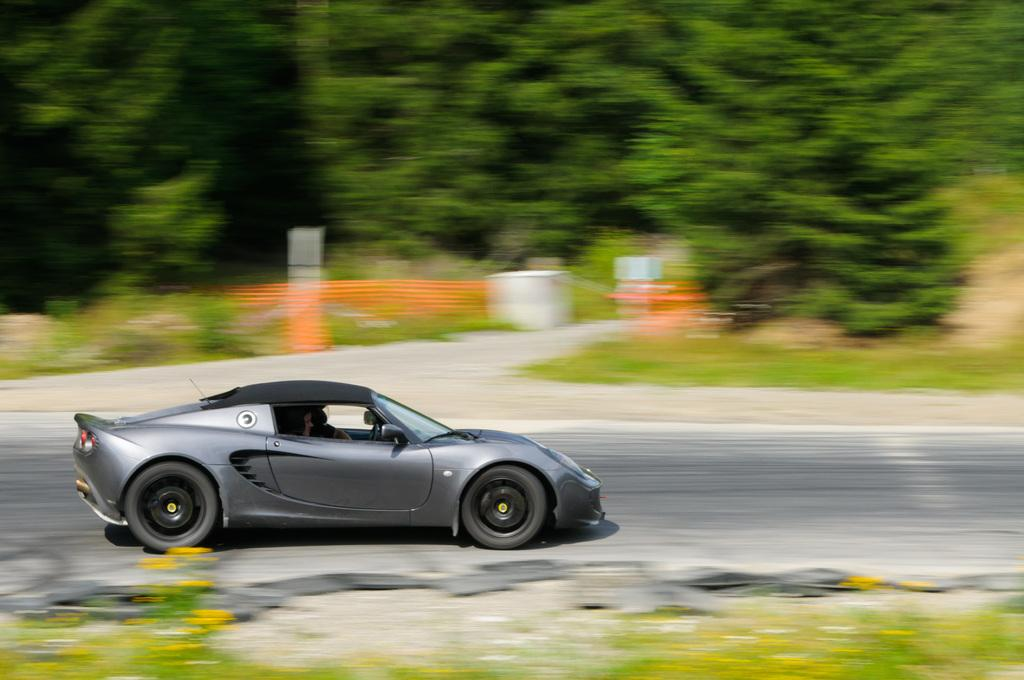What is the main subject of the image? There is a car on the road in the image. What can be seen in the background of the image? There are trees visible in the background of the image. How would you describe the clarity of the image? The background and foreground of the image are blurred. Can you see any rats running around the car in the image? There are no rats present in the image. Did the car get damaged due to an earthquake in the image? There is no indication of an earthquake or any damage to the car in the image. 